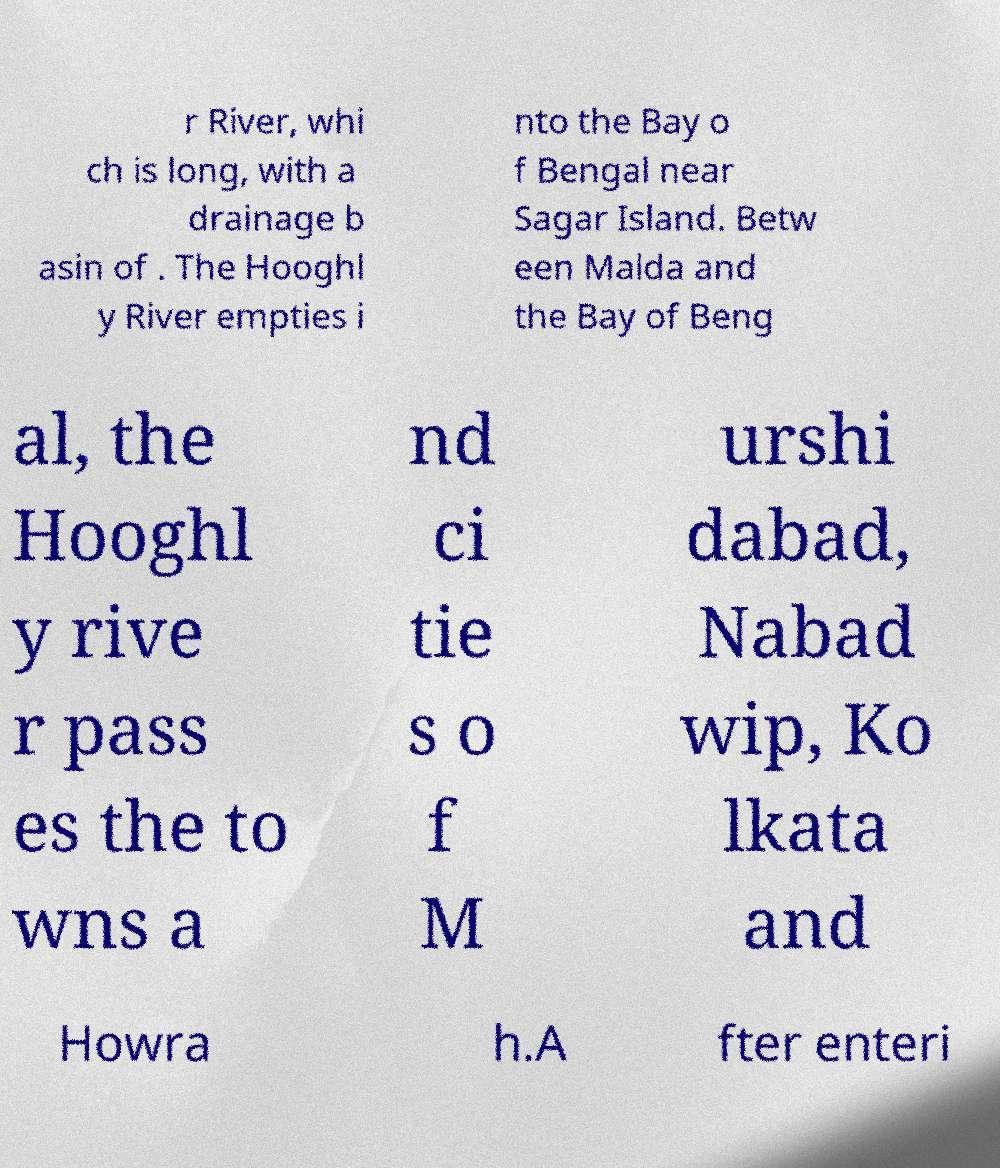Could you assist in decoding the text presented in this image and type it out clearly? r River, whi ch is long, with a drainage b asin of . The Hooghl y River empties i nto the Bay o f Bengal near Sagar Island. Betw een Malda and the Bay of Beng al, the Hooghl y rive r pass es the to wns a nd ci tie s o f M urshi dabad, Nabad wip, Ko lkata and Howra h.A fter enteri 